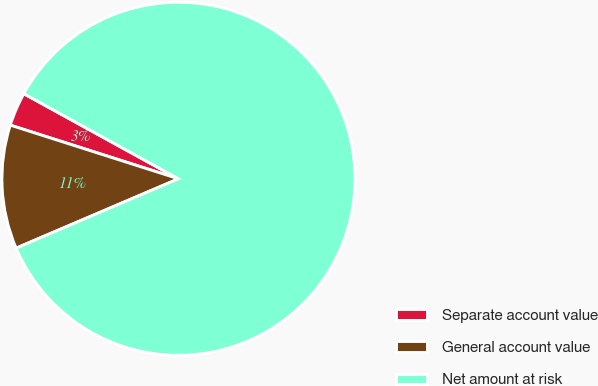<chart> <loc_0><loc_0><loc_500><loc_500><pie_chart><fcel>Separate account value<fcel>General account value<fcel>Net amount at risk<nl><fcel>3.09%<fcel>11.34%<fcel>85.57%<nl></chart> 